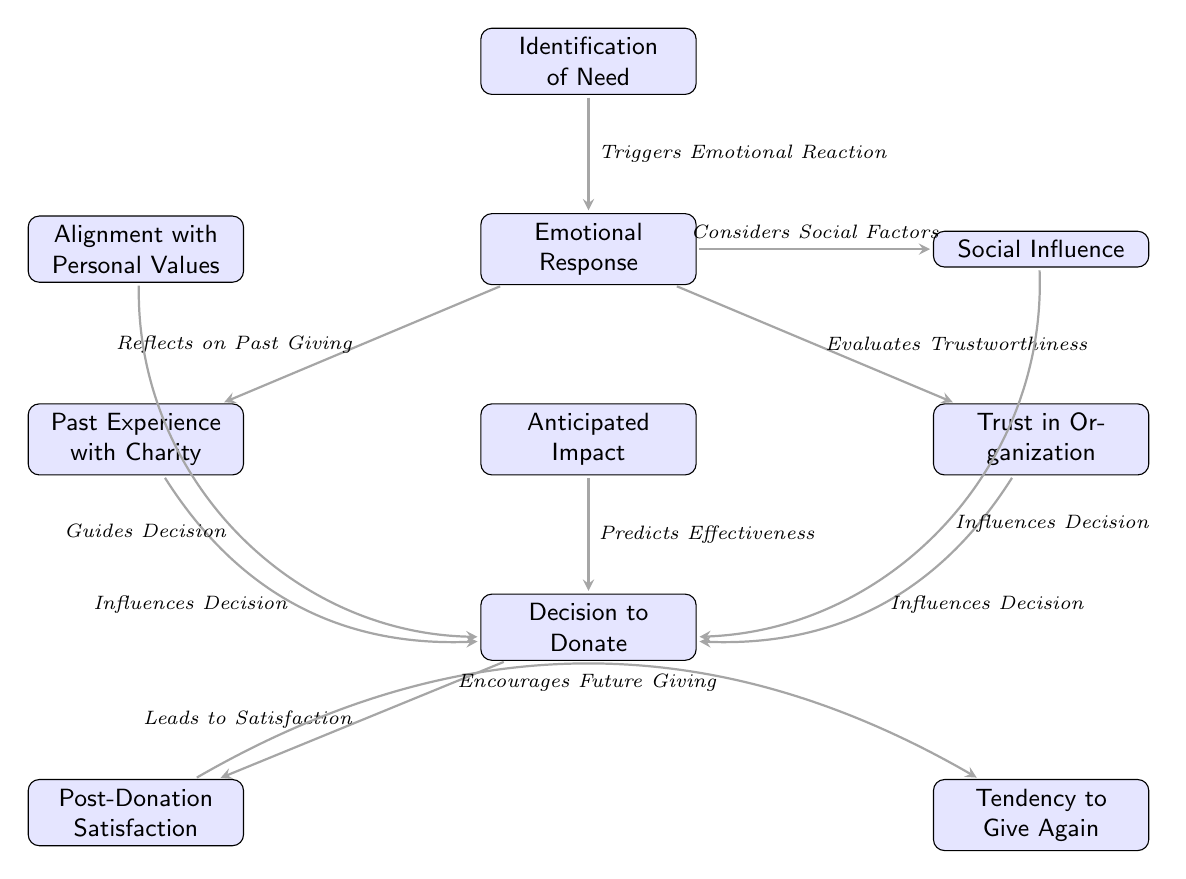What is the first node in the diagram? The first node in the diagram is labeled "Identification of Need," which is the starting point of the charitable giving decision-making process.
Answer: Identification of Need How many nodes are present in the diagram? By counting the boxes in the diagram, I find there are ten nodes representing different stages or factors in the decision-making process.
Answer: Ten What triggers an emotional reaction according to the diagram? The arrow from "Identification of Need" to "Emotional Response" indicates that the identification of need triggers an emotional reaction in individuals considering charitable giving.
Answer: Identification of Need Which node reflects on past experiences with charity? The node labeled "Past Experience with Charity" is connected to the "Emotional Response" node, indicating that individuals reflect on their prior experiences when making giving decisions.
Answer: Past Experience with Charity What does the node "Anticipated Impact" predict? The arrow leading from the "Anticipated Impact" node to the "Decision to Donate" node signifies that anticipated impact predicts the effectiveness of the donation decision.
Answer: Effectiveness Which factors influence the decision to donate? The nodes "Trust in Organization," "Past Experience with Charity," "Social Influence," "Anticipated Impact," and "Alignment with Personal Values" all point to the "Decision to Donate," indicating they influence the decision-making process.
Answer: Five factors What leads to post-donation satisfaction? The connection from "Decision to Donate" to "Post-Donation Satisfaction" demonstrates that making a decision to donate leads to satisfaction after the donation has been made.
Answer: Decision to Donate How does post-donation satisfaction affect future giving? The arrow from "Post-Donation Satisfaction" to "Tendency to Give Again" indicates that satisfaction after donating encourages individuals to give again in the future.
Answer: Encourages Future Giving What emotional response is linked to past experiences with charity? The node "Past Experience with Charity" is linked to the "Emotional Response" node, denoting that individuals reflect on their past experiences, which trigger emotional responses.
Answer: Emotional Response Which node guides the decision-making process? The "Alignment with Personal Values" node influences the "Decision to Donate" by guiding individuals based on their personal beliefs and values.
Answer: Guides Decision 